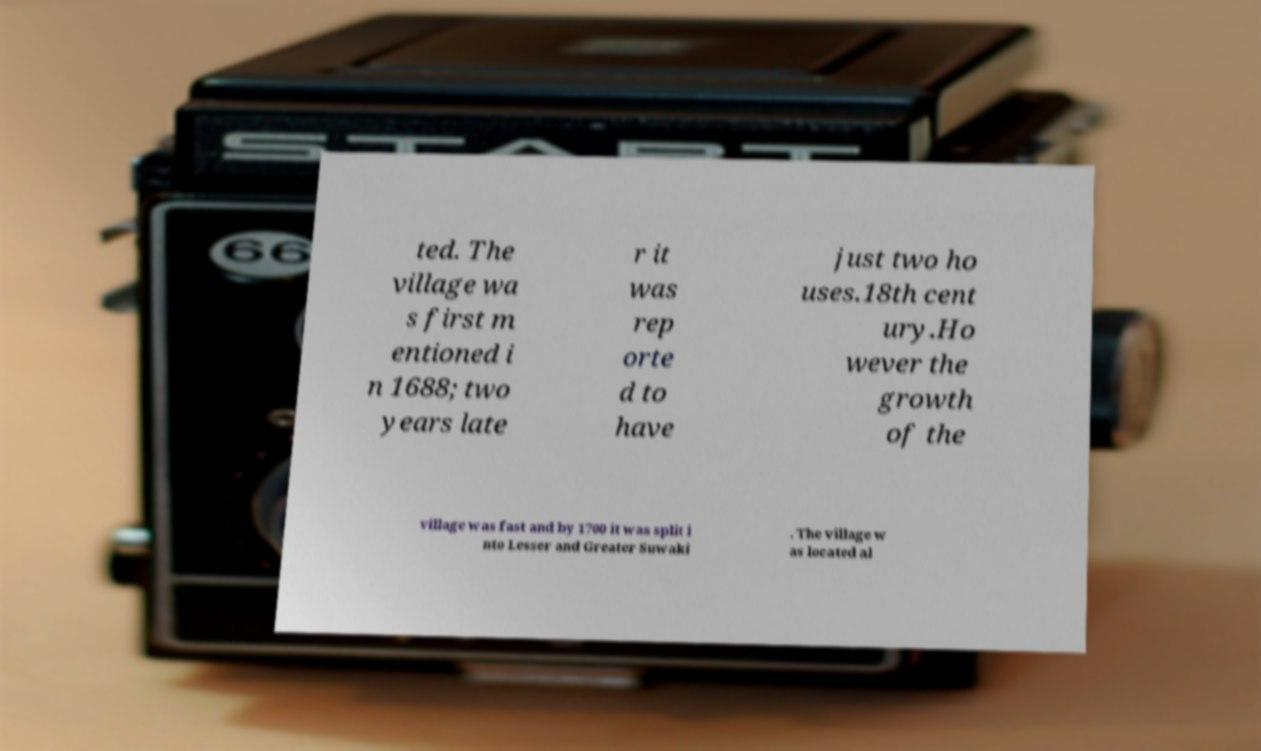Could you extract and type out the text from this image? ted. The village wa s first m entioned i n 1688; two years late r it was rep orte d to have just two ho uses.18th cent ury.Ho wever the growth of the village was fast and by 1700 it was split i nto Lesser and Greater Suwaki . The village w as located al 